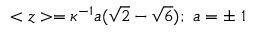Convert formula to latex. <formula><loc_0><loc_0><loc_500><loc_500>< z > = \kappa ^ { - 1 } a ( \sqrt { 2 } - \sqrt { 6 } ) ; a = \pm 1</formula> 